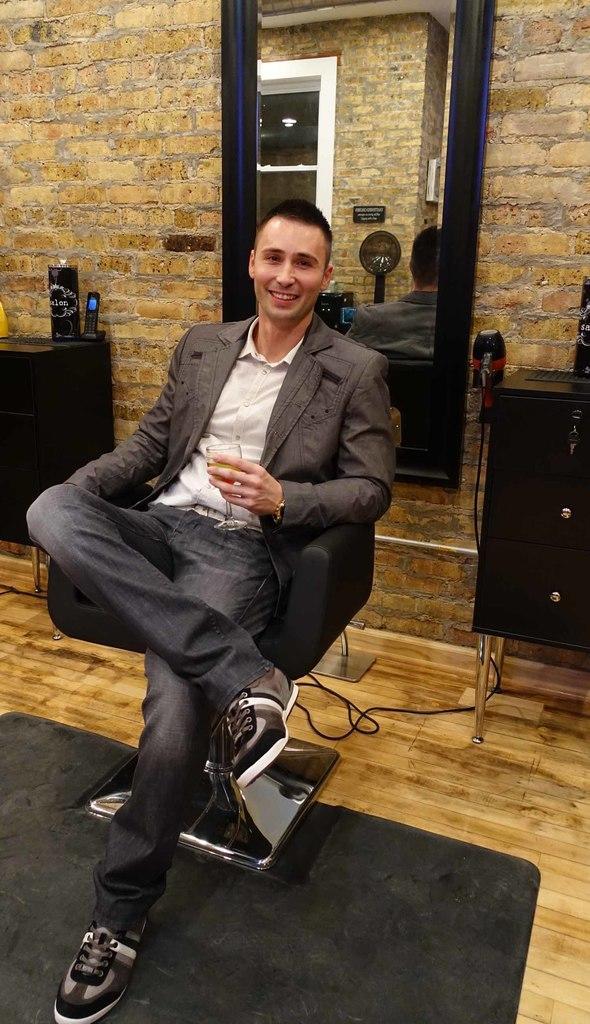Could you give a brief overview of what you see in this image? In this a man is sitting on a chair. At the bottom of the image there is a floor with mat. In the right side of the image there is a cupboard. At the background there is a wall with a big mirror on it. 